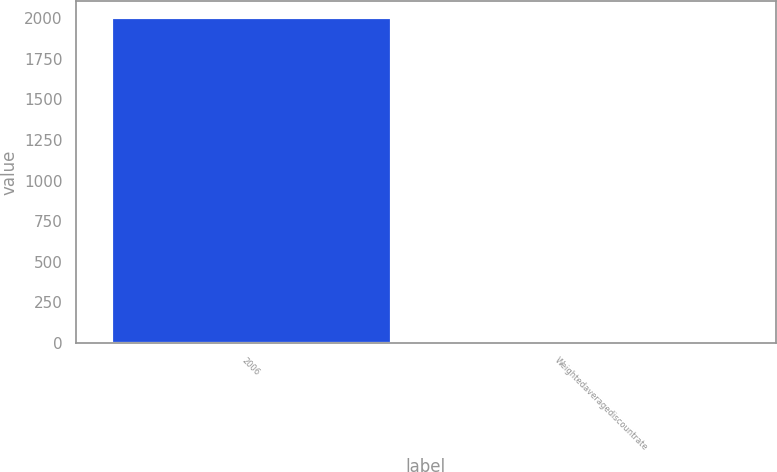<chart> <loc_0><loc_0><loc_500><loc_500><bar_chart><fcel>2006<fcel>Weightedaveragediscountrate<nl><fcel>2005<fcel>5.82<nl></chart> 